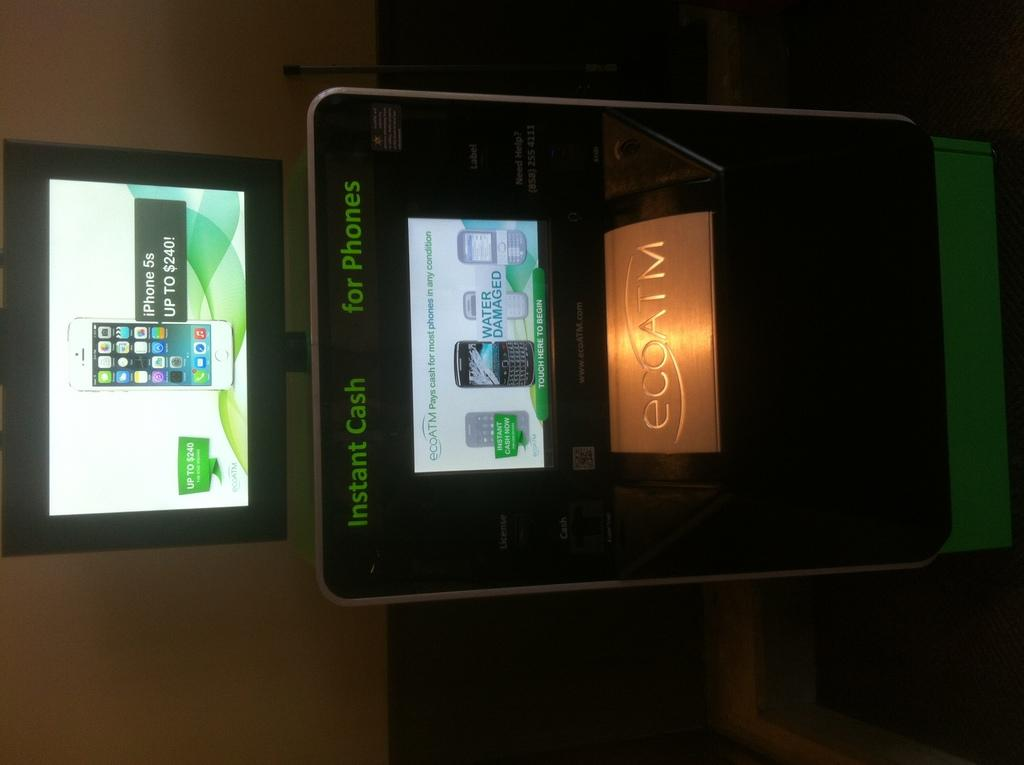<image>
Provide a brief description of the given image. An eco ATM advertises instant cash for phones, offering up to $240 for an iPhone 5s. 